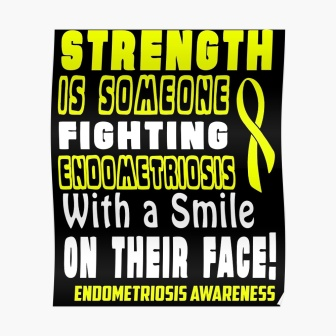Describe a realistic scenario where this poster might be displayed. This poster could be displayed in a community health center’s waiting room, where patients and visitors come for various health services. Placing it there can help raise awareness about endometriosis and might encourage individuals who experience related symptoms to seek medical advice. 